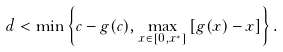Convert formula to latex. <formula><loc_0><loc_0><loc_500><loc_500>d < \min \left \{ c - g ( c ) , \max _ { x \in [ 0 , x ^ { \ast } ] } \left [ g ( x ) - x \right ] \right \} .</formula> 